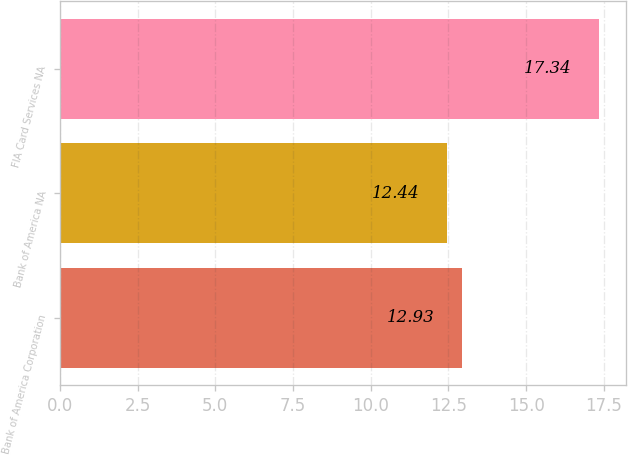Convert chart. <chart><loc_0><loc_0><loc_500><loc_500><bar_chart><fcel>Bank of America Corporation<fcel>Bank of America NA<fcel>FIA Card Services NA<nl><fcel>12.93<fcel>12.44<fcel>17.34<nl></chart> 